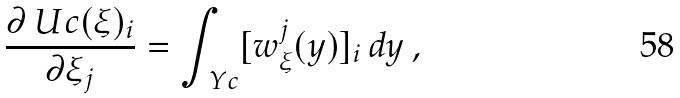Convert formula to latex. <formula><loc_0><loc_0><loc_500><loc_500>\frac { \partial \ U c ( \xi ) _ { i } } { \partial \xi _ { j } } = \int _ { \ Y c } [ w ^ { j } _ { \xi } ( y ) ] _ { i } \, d y \, ,</formula> 